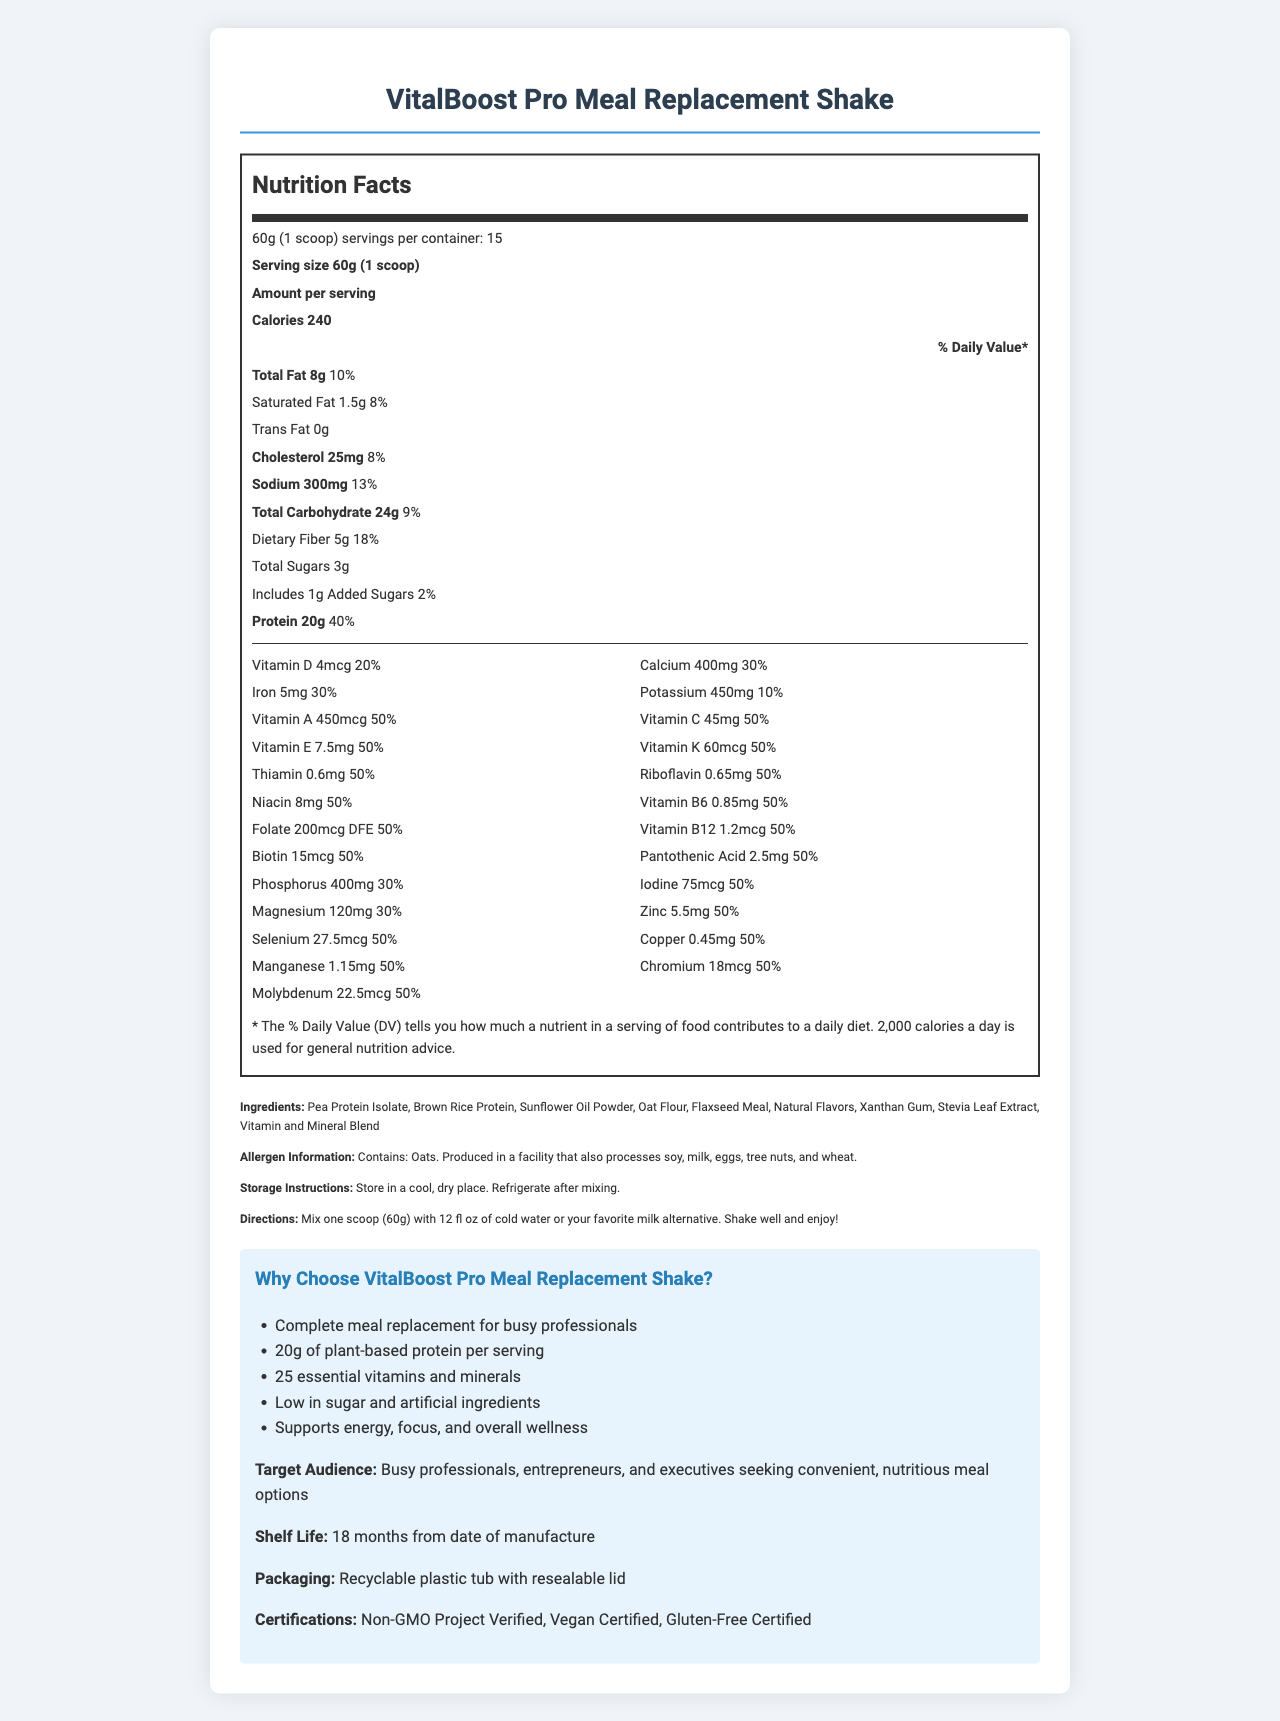what is the serving size of the VitalBoost Pro Meal Replacement Shake? The document specifies the serving size as "60g (1 scoop)" in the nutrition label information section.
Answer: 60g (1 scoop) how many servings are there per container? The document states that there are 15 servings per container in the nutrition facts section.
Answer: 15 what is the protein content per serving? The document lists the amount of protein per serving as 20g in the nutrition label section.
Answer: 20g how much dietary fiber does each serving contain? The document indicates that each serving contains 5g of dietary fiber under the total carbohydrate details.
Answer: 5g what are the main ingredients used in the VitalBoost Pro Meal Replacement Shake? The document lists these as the main ingredients in the section detailing the ingredients.
Answer: Pea Protein Isolate, Brown Rice Protein, Sunflower Oil Powder, Oat Flour, Flaxseed Meal, Natural Flavors, Xanthan Gum, Stevia Leaf Extract, Vitamin and Mineral Blend what is the amount of Vitamin C in each serving and its daily value percentage? The document specifies that each serving contains 45mg of Vitamin C, which is 50% of the daily value.
Answer: 45mg, 50% what is the total fat content per serving and its daily value percentage? The document states that the total fat content per serving is 8g, which corresponds to 10% of the daily value.
Answer: 8g, 10% does the product contain any allergens? If so, what are they? The document mentions that the product contains oats and highlights that it is produced in a facility that also processes soy, milk, eggs, tree nuts, and wheat.
Answer: Yes, contains oats how much added sugar is in one serving? The document indicates that each serving includes 1g of added sugars, which is 2% of the daily value.
Answer: 1g, 2% what certificates does the product have? A. Organic B. Non-GMO C. Vegan The document shows that the product is Non-GMO Project Verified and Vegan Certified, among other certifications.
Answer: B. Non-GMO, C. Vegan which vitamin has the highest daily value percentage per serving? A. Vitamin A B. Vitamin C C. Vitamin K The document states that Vitamin A has a daily value percentage of 50%, which is the highest compared to others like Vitamin C and Vitamin K.
Answer: A. Vitamin A is the VitalBoost Pro Meal Replacement Shake suitable for people who need a gluten-free diet? The document lists "Gluten-Free Certified" in the certifications section, indicating it is suitable for people needing a gluten-free diet.
Answer: Yes what is the main idea of the document? The document gives a detailed overview of this meal replacement shake, focusing on its nutritional benefits for busy professionals.
Answer: The document provides comprehensive information about the VitalBoost Pro Meal Replacement Shake, including its nutrition facts, ingredients, allergen information, usage directions, marketing claims, target audience, shelf life, packaging, and certifications. how much cholesterol is in one serving? The document shows that one serving contains 25mg of cholesterol, which is 8% of the daily value.
Answer: 25mg, 8% what is the expiration or shelf life of the product? The document mentions that the shelf life of the product is 18 months from the date of manufacture.
Answer: 18 months from date of manufacture where should the product be stored and what are the instructions after mixing? The document instructs to store the product in a cool, dry place and to refrigerate it after mixing.
Answer: Store in a cool, dry place. Refrigerate after mixing. how do you prepare the VitalBoost Pro Meal Replacement Shake? The document provides directions on how to prepare the shake, specifying the ingredients and the process.
Answer: Mix one scoop (60g) with 12 fl oz of cold water or your favorite milk alternative. Shake well and enjoy! what is the amount of potassium in each serving? The document lists the potassium content per serving as 450mg with a daily value of 10%.
Answer: 450mg, 10% are there any claims about supporting energy, focus, and wellness? The document includes these claims under the marketing claims section, emphasizing the product supports energy, focus, and overall wellness.
Answer: Yes does this product contain any artificial ingredients? The document highlights that the product is low in sugar and artificial ingredients in the marketing claims section.
Answer: No how much riboflavin is in one serving and its daily value percentage? The document states that each serving contains 0.65mg of riboflavin, which is 50% of the daily value.
Answer: 0.65mg, 50% what is the daily value percentage for dietary fiber in the nutrition facts? A. 10% B. 18% C. 25% The document provides that the daily value percentage for dietary fiber is 18%.
Answer: B. 18% how many calories are in one serving? The document states that one serving contains 240 calories.
Answer: 240 what is the target audience for the VitalBoost Pro Meal Replacement Shake? The document specifies the target audience in the marketing claims section.
Answer: Busy professionals, entrepreneurs, and executives seeking convenient, nutritious meal options what percentage of the daily value of sodium does one serving provide? According to the document, one serving provides 13% of the daily value for sodium.
Answer: 13% what is the price of the VitalBoost Pro Meal Replacement Shake? The document does not contain any information related to the price of the product.
Answer: Not enough information 